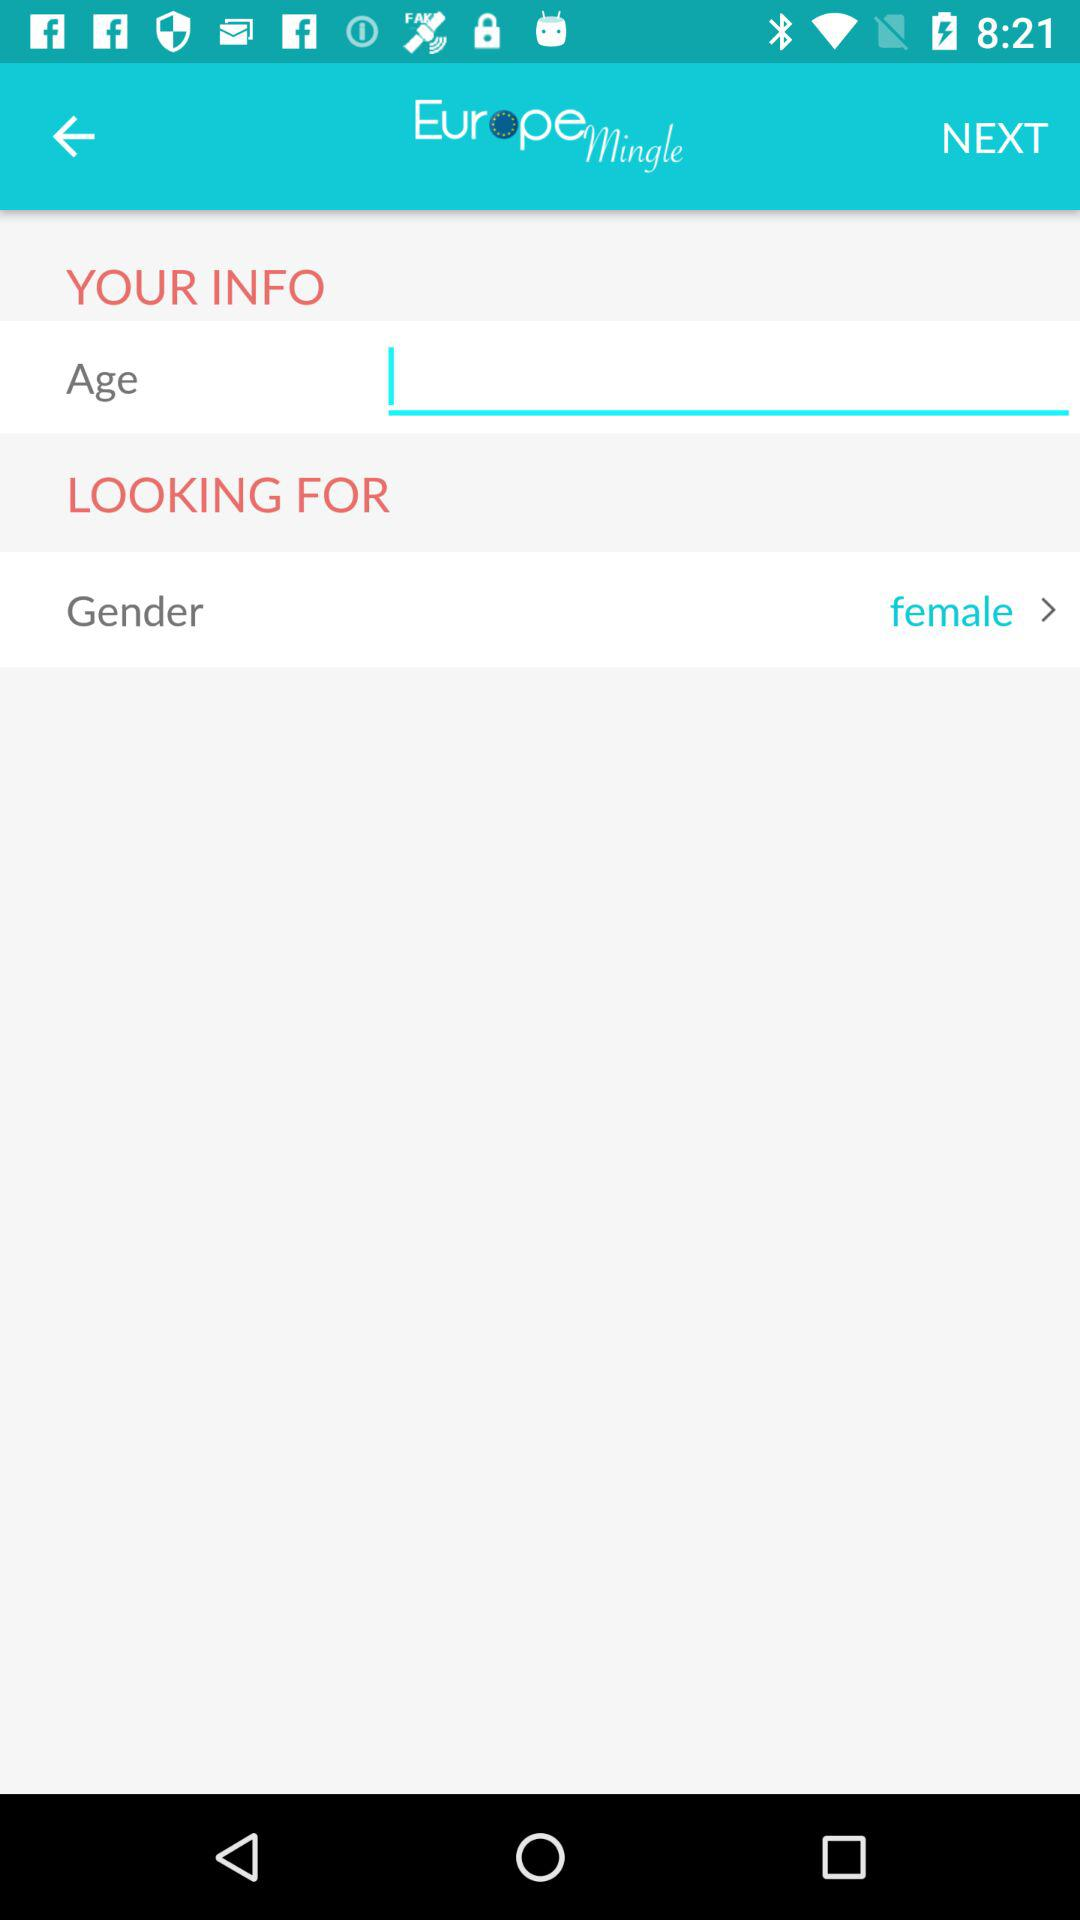What is the application name? The application name is "Europe Mingle". 